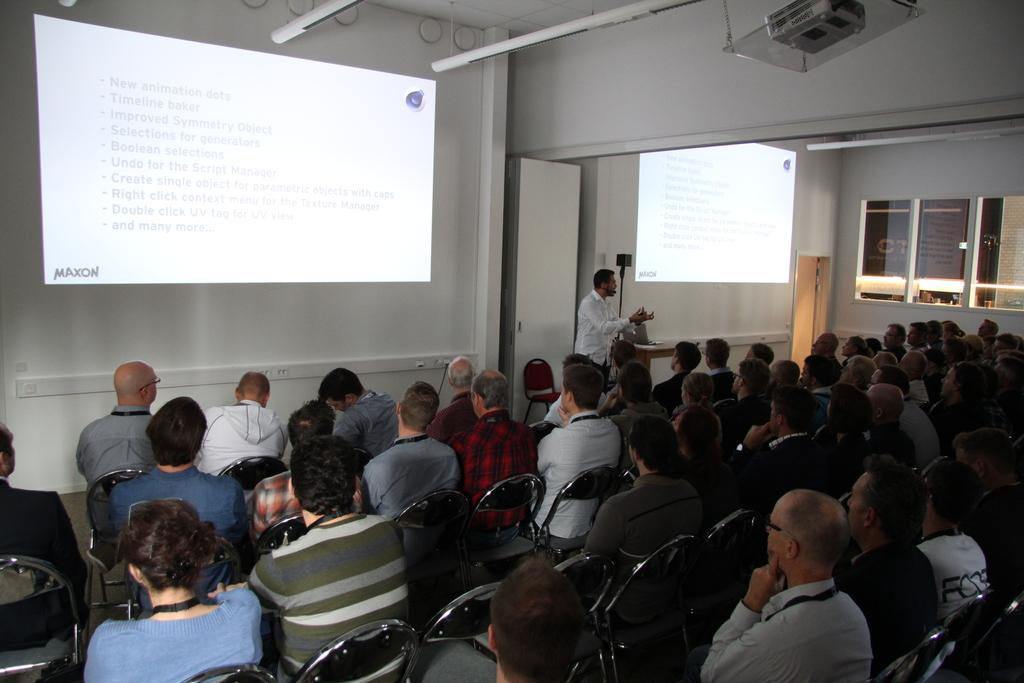What is present on one side of the room in the image? There is a wall in the image. What are the people in the image doing? The people are sitting in chairs. What can be seen on the other side of the room in the image? There is a window in the image. What type of bit is the sheep chewing on in the image? There is no sheep or bit present in the image. Is there a guitar visible in the image? No, there is no guitar present in the image. 